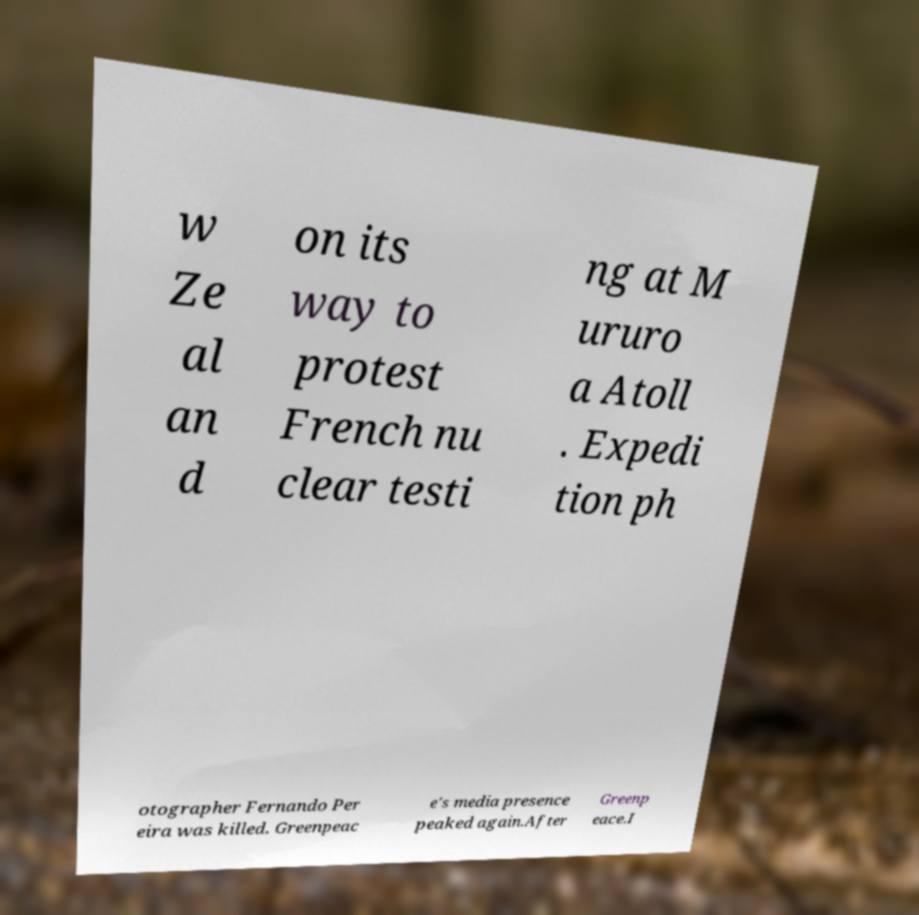Can you accurately transcribe the text from the provided image for me? w Ze al an d on its way to protest French nu clear testi ng at M ururo a Atoll . Expedi tion ph otographer Fernando Per eira was killed. Greenpeac e's media presence peaked again.After Greenp eace.I 